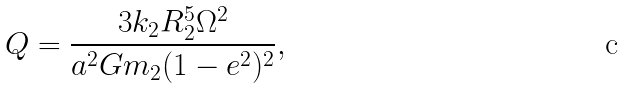Convert formula to latex. <formula><loc_0><loc_0><loc_500><loc_500>Q = \frac { 3 k _ { 2 } R _ { 2 } ^ { 5 } \Omega ^ { 2 } } { a ^ { 2 } G m _ { 2 } ( 1 - e ^ { 2 } ) ^ { 2 } } ,</formula> 